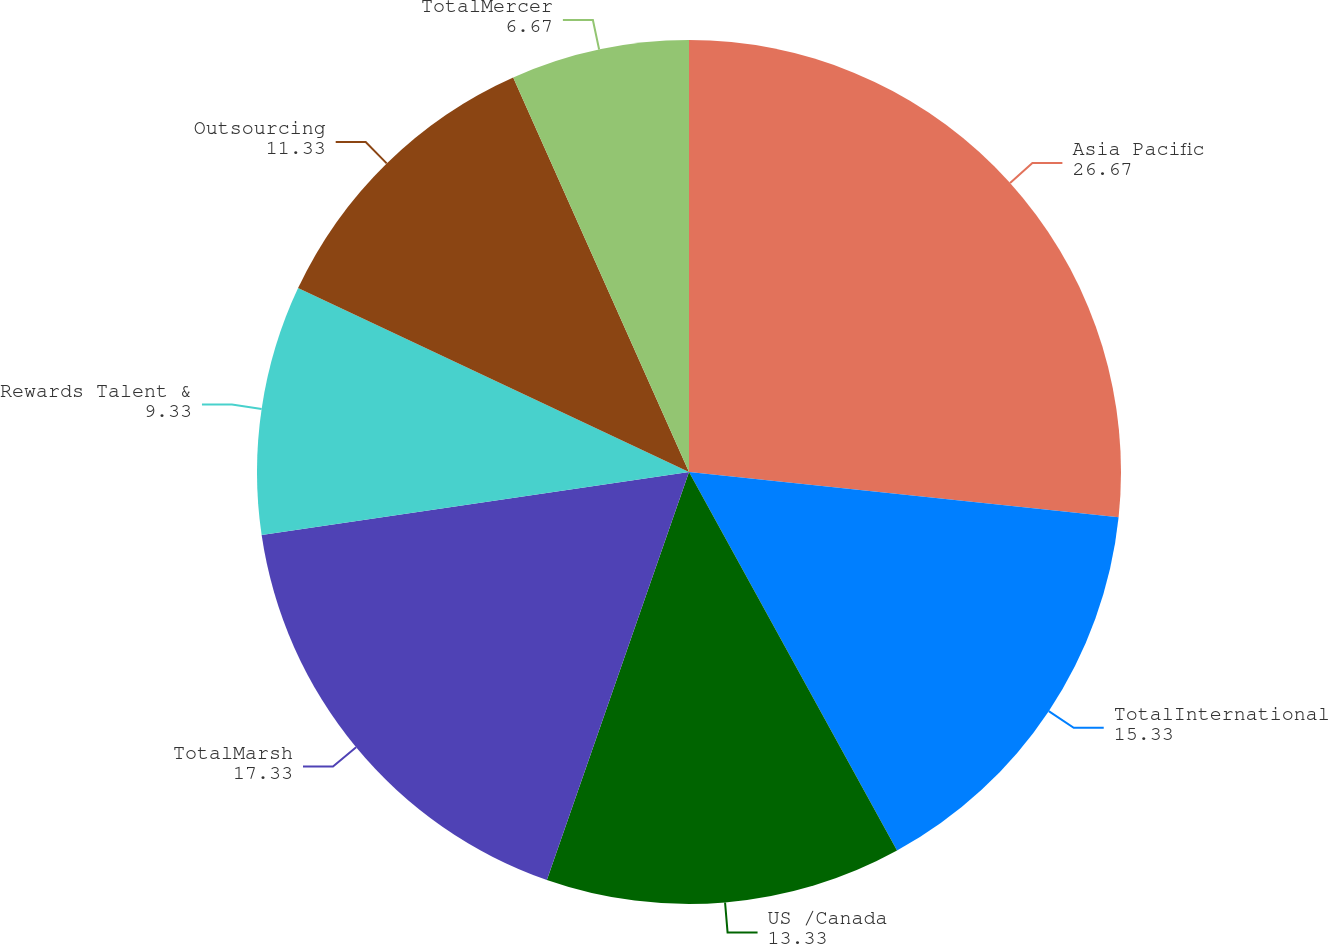<chart> <loc_0><loc_0><loc_500><loc_500><pie_chart><fcel>Asia Pacific<fcel>TotalInternational<fcel>US /Canada<fcel>TotalMarsh<fcel>Rewards Talent &<fcel>Outsourcing<fcel>TotalMercer<nl><fcel>26.67%<fcel>15.33%<fcel>13.33%<fcel>17.33%<fcel>9.33%<fcel>11.33%<fcel>6.67%<nl></chart> 